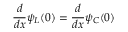<formula> <loc_0><loc_0><loc_500><loc_500>{ \frac { d } { d x } } \psi _ { L } ( 0 ) = { \frac { d } { d x } } \psi _ { C } ( 0 )</formula> 